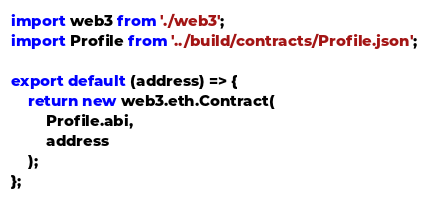Convert code to text. <code><loc_0><loc_0><loc_500><loc_500><_JavaScript_>import web3 from './web3';
import Profile from '../build/contracts/Profile.json';

export default (address) => {
    return new web3.eth.Contract(
        Profile.abi,
        address
    );
};</code> 